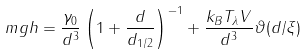<formula> <loc_0><loc_0><loc_500><loc_500>m g h = \frac { \gamma _ { 0 } } { d ^ { 3 } } \left ( 1 + \frac { d } { d _ { 1 / 2 } } \right ) ^ { - 1 } + \frac { k _ { B } T _ { \lambda } V } { d ^ { 3 } } \vartheta ( d / \xi )</formula> 